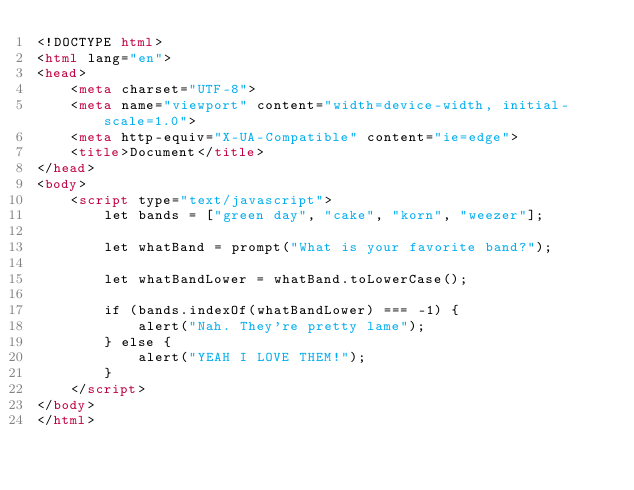<code> <loc_0><loc_0><loc_500><loc_500><_HTML_><!DOCTYPE html>
<html lang="en">
<head>
    <meta charset="UTF-8">
    <meta name="viewport" content="width=device-width, initial-scale=1.0">
    <meta http-equiv="X-UA-Compatible" content="ie=edge">
    <title>Document</title>
</head>
<body>
    <script type="text/javascript">
        let bands = ["green day", "cake", "korn", "weezer"];

        let whatBand = prompt("What is your favorite band?");

        let whatBandLower = whatBand.toLowerCase();

        if (bands.indexOf(whatBandLower) === -1) {
            alert("Nah. They're pretty lame");
        } else {
            alert("YEAH I LOVE THEM!");
        }
    </script>
</body>
</html></code> 